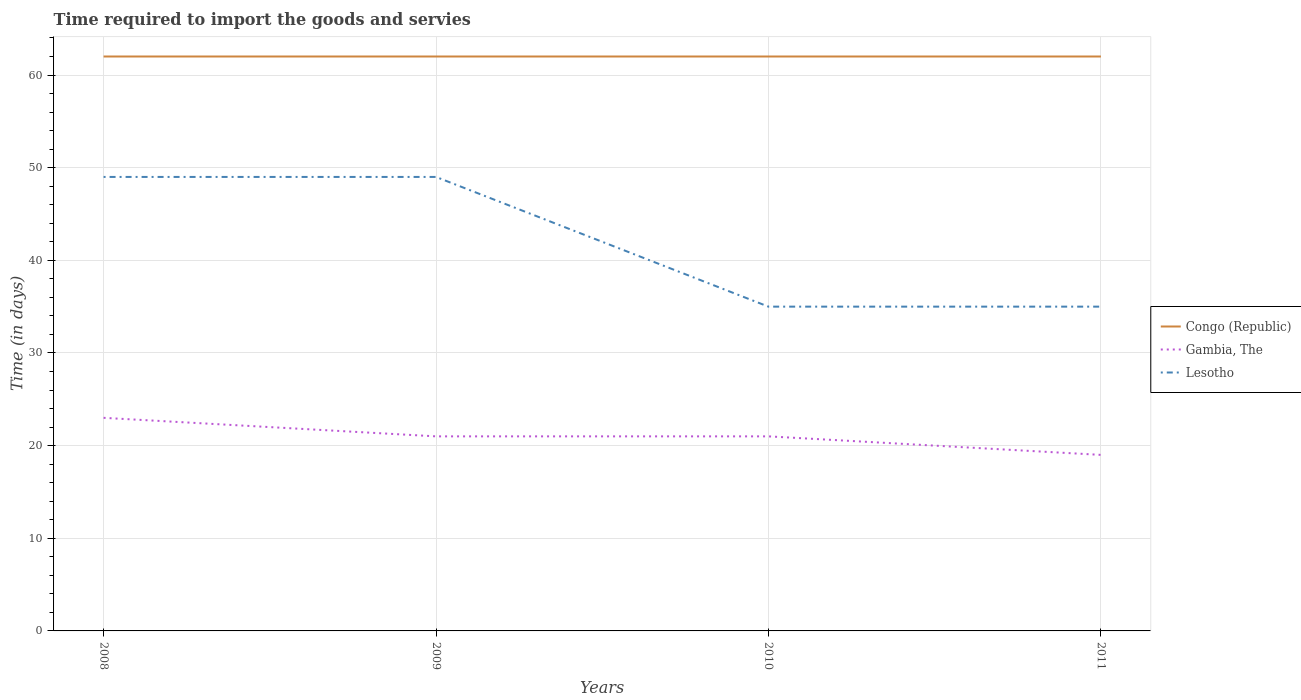How many different coloured lines are there?
Your answer should be very brief. 3. Across all years, what is the maximum number of days required to import the goods and services in Congo (Republic)?
Your response must be concise. 62. In which year was the number of days required to import the goods and services in Congo (Republic) maximum?
Keep it short and to the point. 2008. What is the total number of days required to import the goods and services in Lesotho in the graph?
Provide a succinct answer. 14. What is the difference between the highest and the second highest number of days required to import the goods and services in Congo (Republic)?
Offer a terse response. 0. What is the difference between two consecutive major ticks on the Y-axis?
Provide a short and direct response. 10. Are the values on the major ticks of Y-axis written in scientific E-notation?
Provide a short and direct response. No. Does the graph contain any zero values?
Offer a very short reply. No. Does the graph contain grids?
Your answer should be compact. Yes. Where does the legend appear in the graph?
Your answer should be compact. Center right. How are the legend labels stacked?
Ensure brevity in your answer.  Vertical. What is the title of the graph?
Ensure brevity in your answer.  Time required to import the goods and servies. Does "Serbia" appear as one of the legend labels in the graph?
Make the answer very short. No. What is the label or title of the Y-axis?
Give a very brief answer. Time (in days). What is the Time (in days) in Gambia, The in 2008?
Offer a terse response. 23. What is the Time (in days) of Lesotho in 2009?
Keep it short and to the point. 49. What is the Time (in days) of Congo (Republic) in 2010?
Offer a very short reply. 62. What is the Time (in days) in Gambia, The in 2010?
Your answer should be compact. 21. What is the Time (in days) of Gambia, The in 2011?
Provide a succinct answer. 19. What is the Time (in days) of Lesotho in 2011?
Provide a succinct answer. 35. Across all years, what is the maximum Time (in days) of Lesotho?
Provide a short and direct response. 49. Across all years, what is the minimum Time (in days) of Congo (Republic)?
Your response must be concise. 62. Across all years, what is the minimum Time (in days) in Gambia, The?
Make the answer very short. 19. What is the total Time (in days) of Congo (Republic) in the graph?
Your answer should be very brief. 248. What is the total Time (in days) of Lesotho in the graph?
Your answer should be compact. 168. What is the difference between the Time (in days) in Lesotho in 2008 and that in 2009?
Your answer should be very brief. 0. What is the difference between the Time (in days) in Lesotho in 2008 and that in 2010?
Make the answer very short. 14. What is the difference between the Time (in days) in Gambia, The in 2008 and that in 2011?
Your answer should be very brief. 4. What is the difference between the Time (in days) of Congo (Republic) in 2009 and that in 2010?
Your answer should be very brief. 0. What is the difference between the Time (in days) of Gambia, The in 2009 and that in 2011?
Provide a succinct answer. 2. What is the difference between the Time (in days) of Lesotho in 2009 and that in 2011?
Ensure brevity in your answer.  14. What is the difference between the Time (in days) of Congo (Republic) in 2010 and that in 2011?
Offer a terse response. 0. What is the difference between the Time (in days) in Gambia, The in 2010 and that in 2011?
Provide a short and direct response. 2. What is the difference between the Time (in days) of Lesotho in 2010 and that in 2011?
Offer a very short reply. 0. What is the difference between the Time (in days) in Congo (Republic) in 2008 and the Time (in days) in Gambia, The in 2009?
Ensure brevity in your answer.  41. What is the difference between the Time (in days) of Congo (Republic) in 2008 and the Time (in days) of Lesotho in 2009?
Provide a short and direct response. 13. What is the difference between the Time (in days) in Gambia, The in 2008 and the Time (in days) in Lesotho in 2009?
Provide a short and direct response. -26. What is the difference between the Time (in days) in Gambia, The in 2008 and the Time (in days) in Lesotho in 2011?
Keep it short and to the point. -12. What is the difference between the Time (in days) in Congo (Republic) in 2009 and the Time (in days) in Lesotho in 2010?
Your answer should be very brief. 27. What is the difference between the Time (in days) of Congo (Republic) in 2009 and the Time (in days) of Gambia, The in 2011?
Your answer should be compact. 43. What is the difference between the Time (in days) of Congo (Republic) in 2009 and the Time (in days) of Lesotho in 2011?
Provide a succinct answer. 27. What is the difference between the Time (in days) in Congo (Republic) in 2010 and the Time (in days) in Gambia, The in 2011?
Ensure brevity in your answer.  43. What is the difference between the Time (in days) in Gambia, The in 2010 and the Time (in days) in Lesotho in 2011?
Offer a very short reply. -14. What is the average Time (in days) in Congo (Republic) per year?
Offer a terse response. 62. What is the average Time (in days) in Gambia, The per year?
Keep it short and to the point. 21. What is the average Time (in days) of Lesotho per year?
Ensure brevity in your answer.  42. In the year 2008, what is the difference between the Time (in days) of Congo (Republic) and Time (in days) of Lesotho?
Keep it short and to the point. 13. In the year 2010, what is the difference between the Time (in days) of Congo (Republic) and Time (in days) of Gambia, The?
Your response must be concise. 41. In the year 2010, what is the difference between the Time (in days) in Congo (Republic) and Time (in days) in Lesotho?
Your answer should be compact. 27. In the year 2010, what is the difference between the Time (in days) of Gambia, The and Time (in days) of Lesotho?
Your answer should be very brief. -14. In the year 2011, what is the difference between the Time (in days) of Congo (Republic) and Time (in days) of Gambia, The?
Offer a very short reply. 43. In the year 2011, what is the difference between the Time (in days) of Gambia, The and Time (in days) of Lesotho?
Your answer should be very brief. -16. What is the ratio of the Time (in days) in Congo (Republic) in 2008 to that in 2009?
Your answer should be very brief. 1. What is the ratio of the Time (in days) in Gambia, The in 2008 to that in 2009?
Offer a very short reply. 1.1. What is the ratio of the Time (in days) in Lesotho in 2008 to that in 2009?
Provide a succinct answer. 1. What is the ratio of the Time (in days) in Congo (Republic) in 2008 to that in 2010?
Provide a succinct answer. 1. What is the ratio of the Time (in days) of Gambia, The in 2008 to that in 2010?
Ensure brevity in your answer.  1.1. What is the ratio of the Time (in days) in Lesotho in 2008 to that in 2010?
Give a very brief answer. 1.4. What is the ratio of the Time (in days) in Gambia, The in 2008 to that in 2011?
Give a very brief answer. 1.21. What is the ratio of the Time (in days) of Gambia, The in 2009 to that in 2011?
Offer a very short reply. 1.11. What is the ratio of the Time (in days) of Lesotho in 2009 to that in 2011?
Offer a very short reply. 1.4. What is the ratio of the Time (in days) in Congo (Republic) in 2010 to that in 2011?
Offer a terse response. 1. What is the ratio of the Time (in days) in Gambia, The in 2010 to that in 2011?
Give a very brief answer. 1.11. What is the ratio of the Time (in days) of Lesotho in 2010 to that in 2011?
Give a very brief answer. 1. What is the difference between the highest and the second highest Time (in days) of Lesotho?
Your response must be concise. 0. What is the difference between the highest and the lowest Time (in days) of Congo (Republic)?
Keep it short and to the point. 0. What is the difference between the highest and the lowest Time (in days) in Gambia, The?
Keep it short and to the point. 4. What is the difference between the highest and the lowest Time (in days) of Lesotho?
Your answer should be compact. 14. 